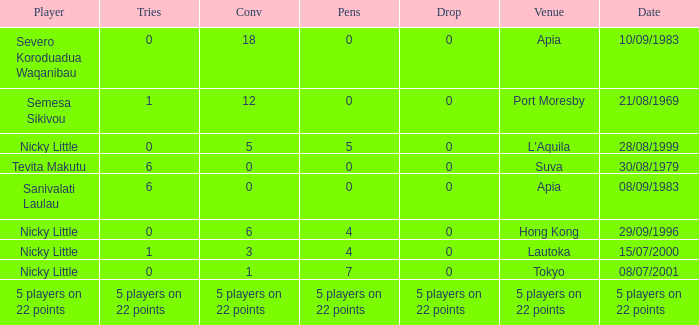What is the number of conversions with 0 pens and 0 attempts? 18.0. 